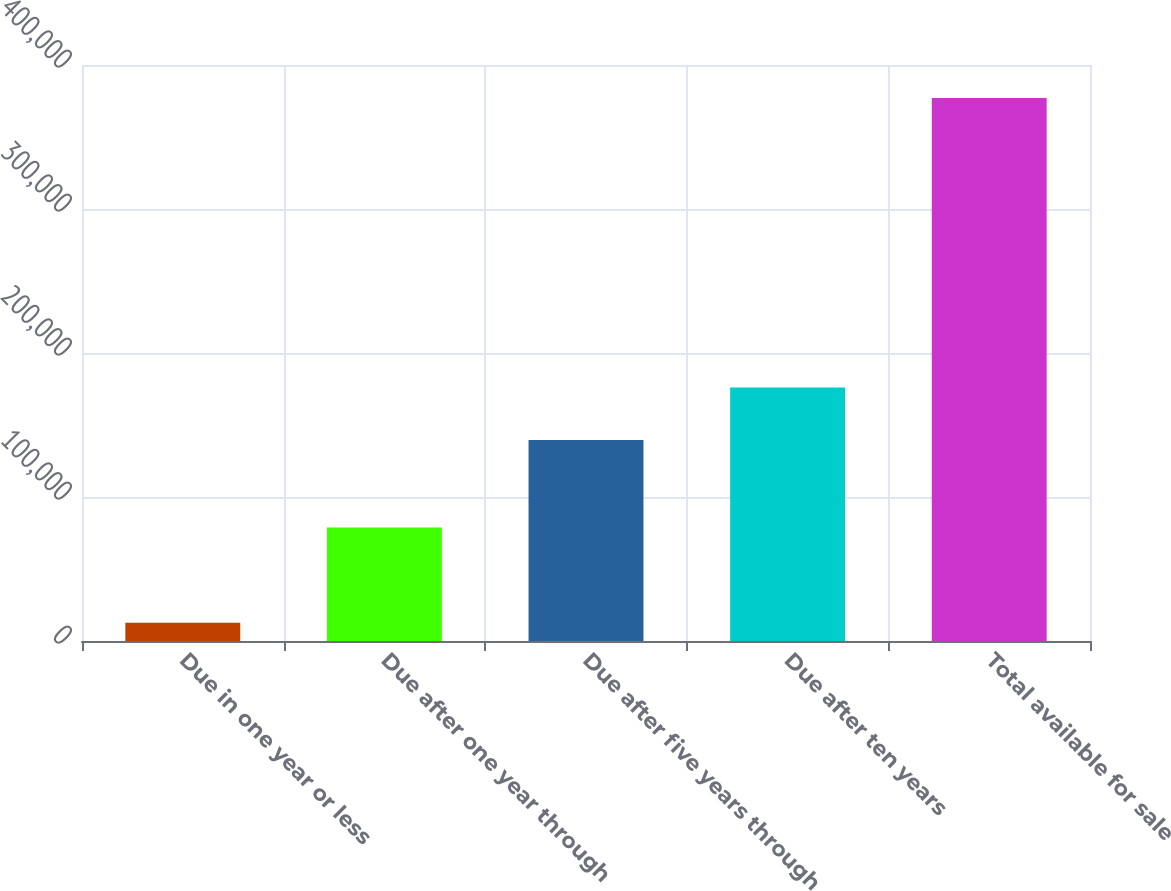Convert chart to OTSL. <chart><loc_0><loc_0><loc_500><loc_500><bar_chart><fcel>Due in one year or less<fcel>Due after one year through<fcel>Due after five years through<fcel>Due after ten years<fcel>Total available for sale<nl><fcel>12730<fcel>78800<fcel>139579<fcel>176022<fcel>377163<nl></chart> 